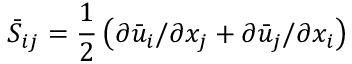Convert formula to latex. <formula><loc_0><loc_0><loc_500><loc_500>\bar { S } _ { i j } = \frac { 1 } { 2 } \left ( \partial \bar { u } _ { i } / \partial x _ { j } + \partial \bar { u } _ { j } / \partial x _ { i } \right )</formula> 